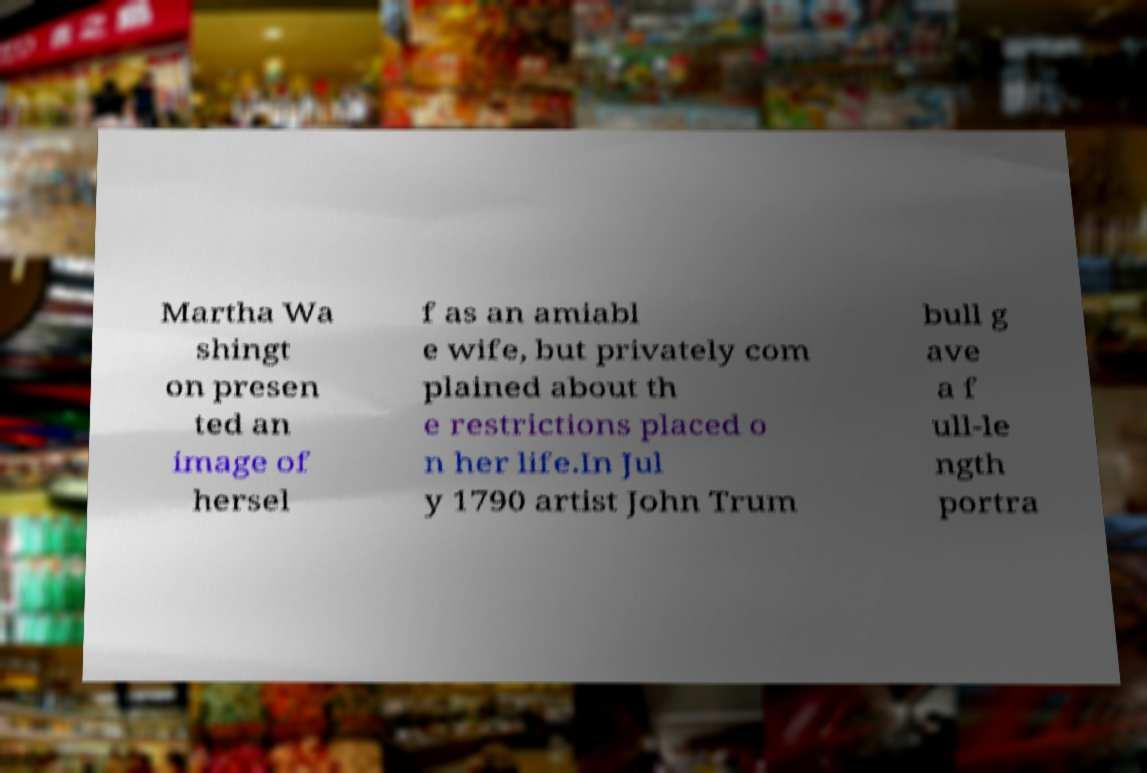What messages or text are displayed in this image? I need them in a readable, typed format. Martha Wa shingt on presen ted an image of hersel f as an amiabl e wife, but privately com plained about th e restrictions placed o n her life.In Jul y 1790 artist John Trum bull g ave a f ull-le ngth portra 